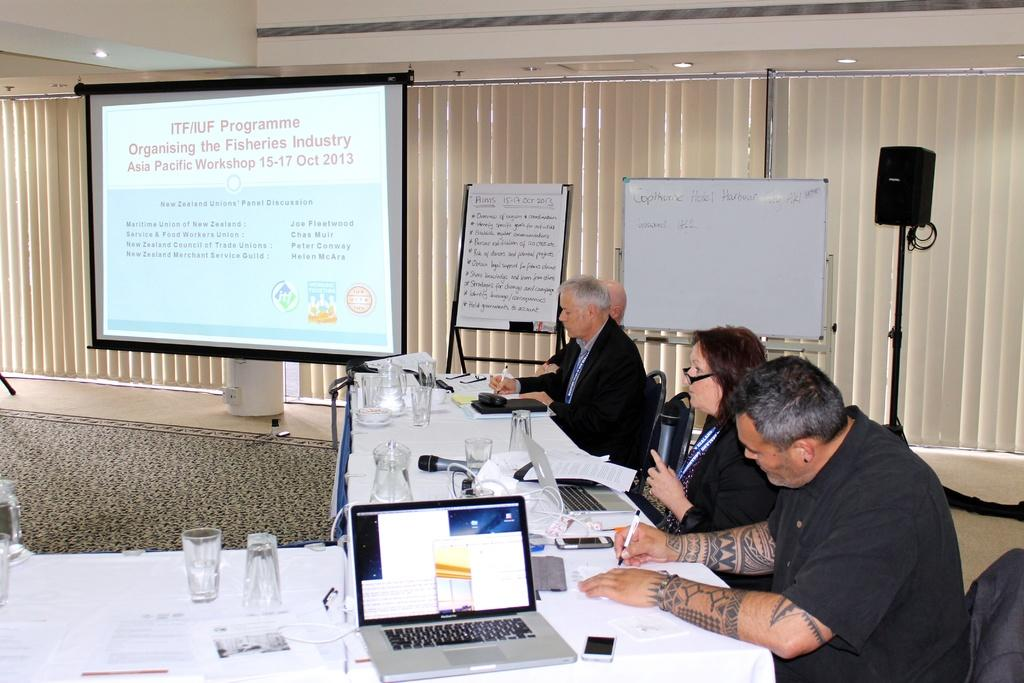Provide a one-sentence caption for the provided image. A group is having a presentation around a number of table with a screen displaying the days Programme. 